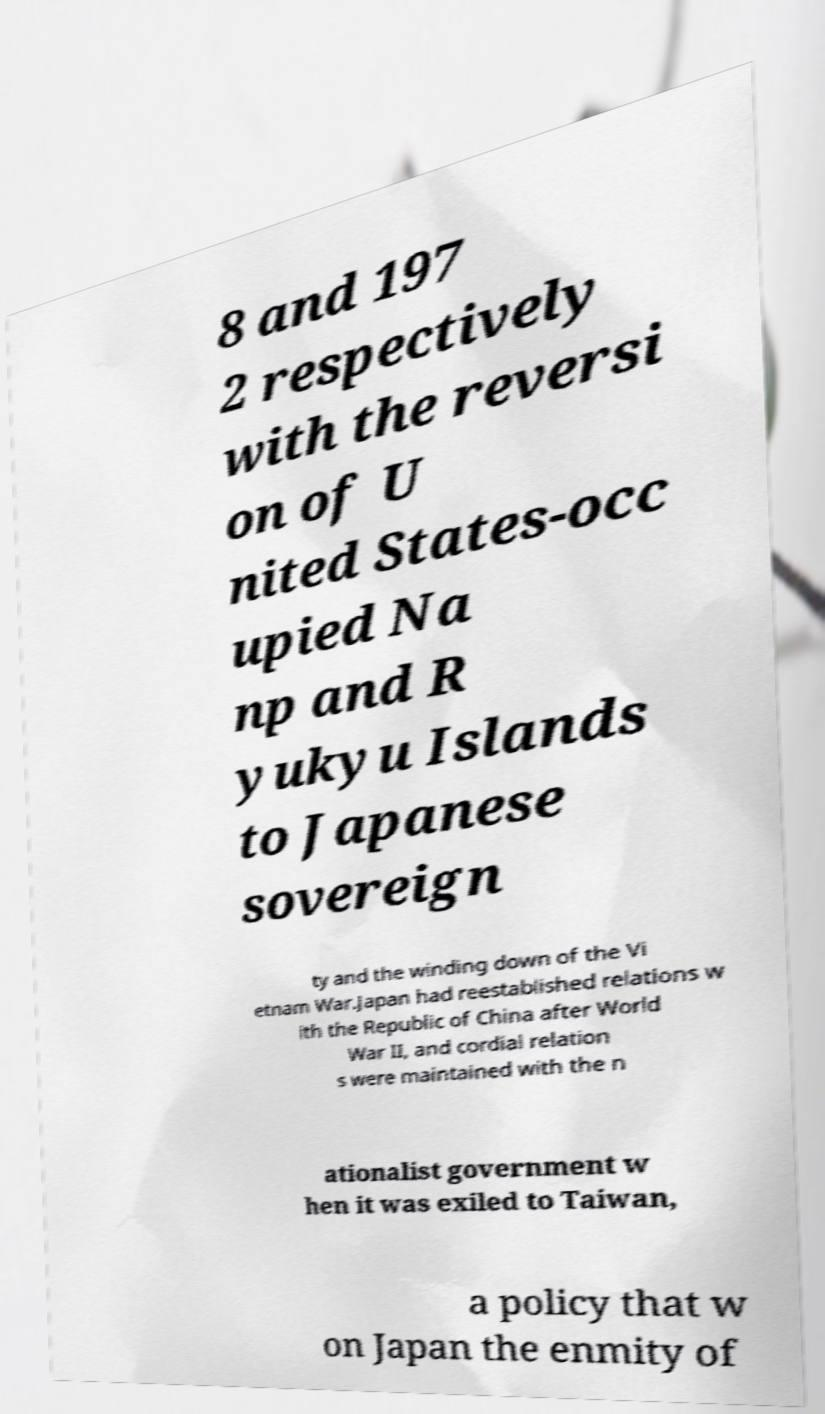Please identify and transcribe the text found in this image. 8 and 197 2 respectively with the reversi on of U nited States-occ upied Na np and R yukyu Islands to Japanese sovereign ty and the winding down of the Vi etnam War.Japan had reestablished relations w ith the Republic of China after World War II, and cordial relation s were maintained with the n ationalist government w hen it was exiled to Taiwan, a policy that w on Japan the enmity of 